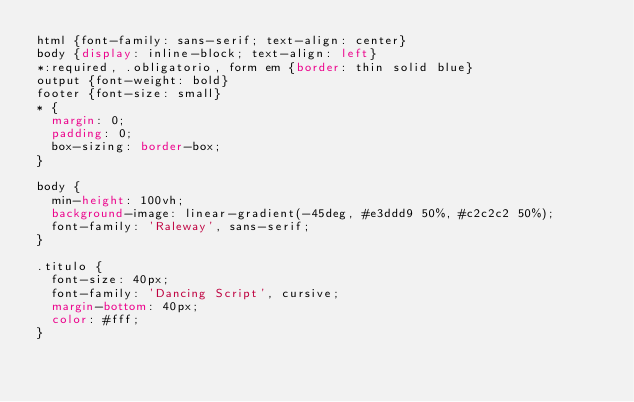Convert code to text. <code><loc_0><loc_0><loc_500><loc_500><_CSS_>html {font-family: sans-serif; text-align: center}
body {display: inline-block; text-align: left}
*:required, .obligatorio, form em {border: thin solid blue}
output {font-weight: bold}
footer {font-size: small}
* {
  margin: 0; 
  padding: 0;
  box-sizing: border-box;
}

body { 
  min-height: 100vh;
  background-image: linear-gradient(-45deg, #e3ddd9 50%, #c2c2c2 50%);
  font-family: 'Raleway', sans-serif;
}

.titulo {
  font-size: 40px;
  font-family: 'Dancing Script', cursive;
  margin-bottom: 40px;
  color: #fff;
}</code> 